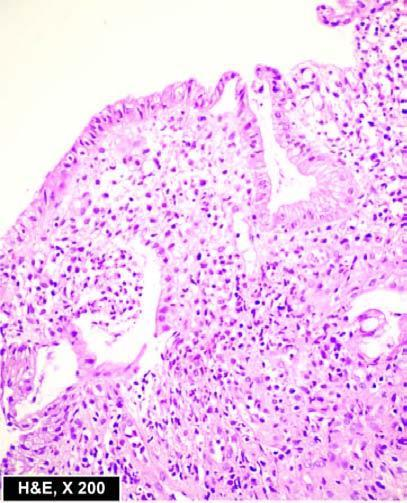how are the microscopic features seen superficial ulcerations?
Answer the question using a single word or phrase. With mucosal infiltration 